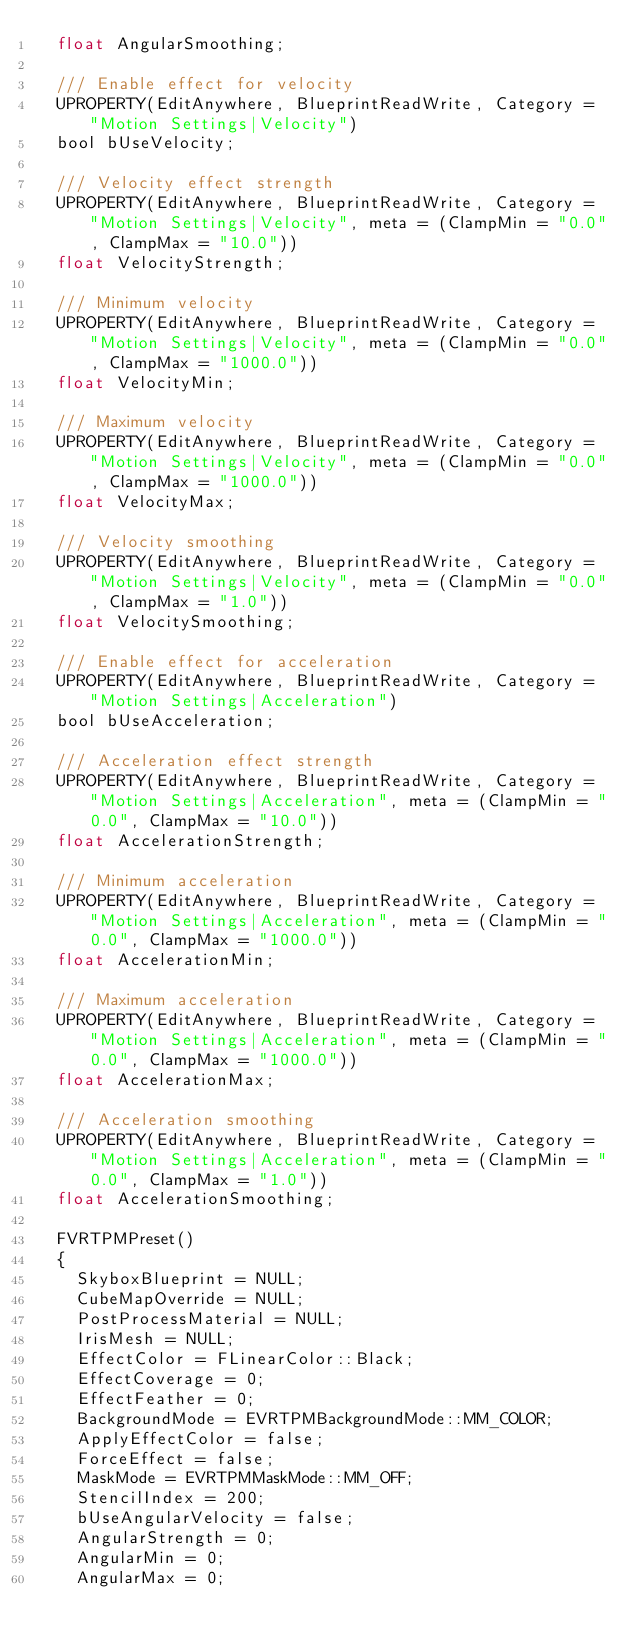Convert code to text. <code><loc_0><loc_0><loc_500><loc_500><_C_>	float AngularSmoothing;

	/// Enable effect for velocity
	UPROPERTY(EditAnywhere, BlueprintReadWrite, Category = "Motion Settings|Velocity")
	bool bUseVelocity;

	/// Velocity effect strength
	UPROPERTY(EditAnywhere, BlueprintReadWrite, Category = "Motion Settings|Velocity", meta = (ClampMin = "0.0", ClampMax = "10.0"))
	float VelocityStrength;

	/// Minimum velocity
	UPROPERTY(EditAnywhere, BlueprintReadWrite, Category = "Motion Settings|Velocity", meta = (ClampMin = "0.0", ClampMax = "1000.0"))
	float VelocityMin;

	/// Maximum velocity
	UPROPERTY(EditAnywhere, BlueprintReadWrite, Category = "Motion Settings|Velocity", meta = (ClampMin = "0.0", ClampMax = "1000.0"))
	float VelocityMax;

	/// Velocity smoothing
	UPROPERTY(EditAnywhere, BlueprintReadWrite, Category = "Motion Settings|Velocity", meta = (ClampMin = "0.0", ClampMax = "1.0"))
	float VelocitySmoothing;

	/// Enable effect for acceleration
	UPROPERTY(EditAnywhere, BlueprintReadWrite, Category = "Motion Settings|Acceleration")
	bool bUseAcceleration;

	/// Acceleration effect strength
	UPROPERTY(EditAnywhere, BlueprintReadWrite, Category = "Motion Settings|Acceleration", meta = (ClampMin = "0.0", ClampMax = "10.0"))
	float AccelerationStrength;

	/// Minimum acceleration
	UPROPERTY(EditAnywhere, BlueprintReadWrite, Category = "Motion Settings|Acceleration", meta = (ClampMin = "0.0", ClampMax = "1000.0"))
	float AccelerationMin;

	/// Maximum acceleration
	UPROPERTY(EditAnywhere, BlueprintReadWrite, Category = "Motion Settings|Acceleration", meta = (ClampMin = "0.0", ClampMax = "1000.0"))
	float AccelerationMax;

	/// Acceleration smoothing
	UPROPERTY(EditAnywhere, BlueprintReadWrite, Category = "Motion Settings|Acceleration", meta = (ClampMin = "0.0", ClampMax = "1.0"))
	float AccelerationSmoothing;

	FVRTPMPreset()
	{
		SkyboxBlueprint = NULL;
		CubeMapOverride = NULL;
		PostProcessMaterial = NULL;
		IrisMesh = NULL;
		EffectColor = FLinearColor::Black;
		EffectCoverage = 0;
		EffectFeather = 0;
		BackgroundMode = EVRTPMBackgroundMode::MM_COLOR;
		ApplyEffectColor = false;
		ForceEffect = false;
		MaskMode = EVRTPMMaskMode::MM_OFF;
		StencilIndex = 200;
		bUseAngularVelocity = false;
		AngularStrength = 0;
		AngularMin = 0;
		AngularMax = 0;</code> 